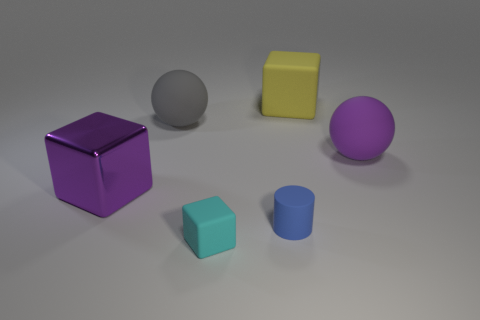How would you describe the arrangement of objects in this image? The objects in this image are arranged in a loosely scattered configuration across the floor. The placement seems intentional but casual, creating an aesthetically pleasing composition with varying shapes and colors. The arrangement allows each object to be distinct while maintaining a harmonious balance within the scene.  Can you speculate on the purpose of these objects? Given their simplicity and the variety of shapes and colors, these objects could be used for several purposes, such as elements in a graphic design project, aids in a photography composition study, or as models in a 3D rendering tutorial to teach about lighting, shading, and perspective. 